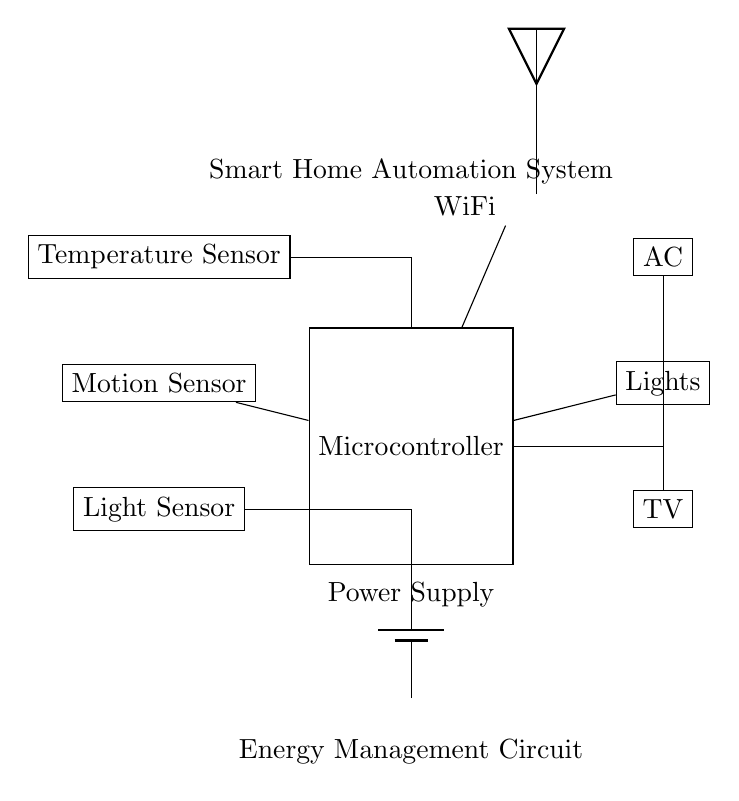What is the role of the microcontroller in this circuit? The microcontroller acts as the central processing unit that receives input from various sensors and controls household appliances based on those inputs.
Answer: Central processing unit How many sensors are connected to the microcontroller? There are three sensors connected to the microcontroller: a temperature sensor, a motion sensor, and a light sensor.
Answer: Three Which appliances are directly controlled by the microcontroller? The microcontroller directly controls three appliances: the air conditioning unit, lights, and television.
Answer: Air conditioning unit, lights, television What type of communication does this system use? This system uses WiFi communication for remote access and control.
Answer: WiFi Why is the power supply crucial in this circuit? The power supply is essential because it provides the necessary electrical energy to operate the microcontroller and connected components, ensuring that the entire system functions reliably.
Answer: Electrical energy provision If the temperature sensor detects high temperature, which appliance will likely be activated? If the temperature sensor detects high temperature, it will likely activate the air conditioning unit to cool down the environment.
Answer: Air conditioning unit 